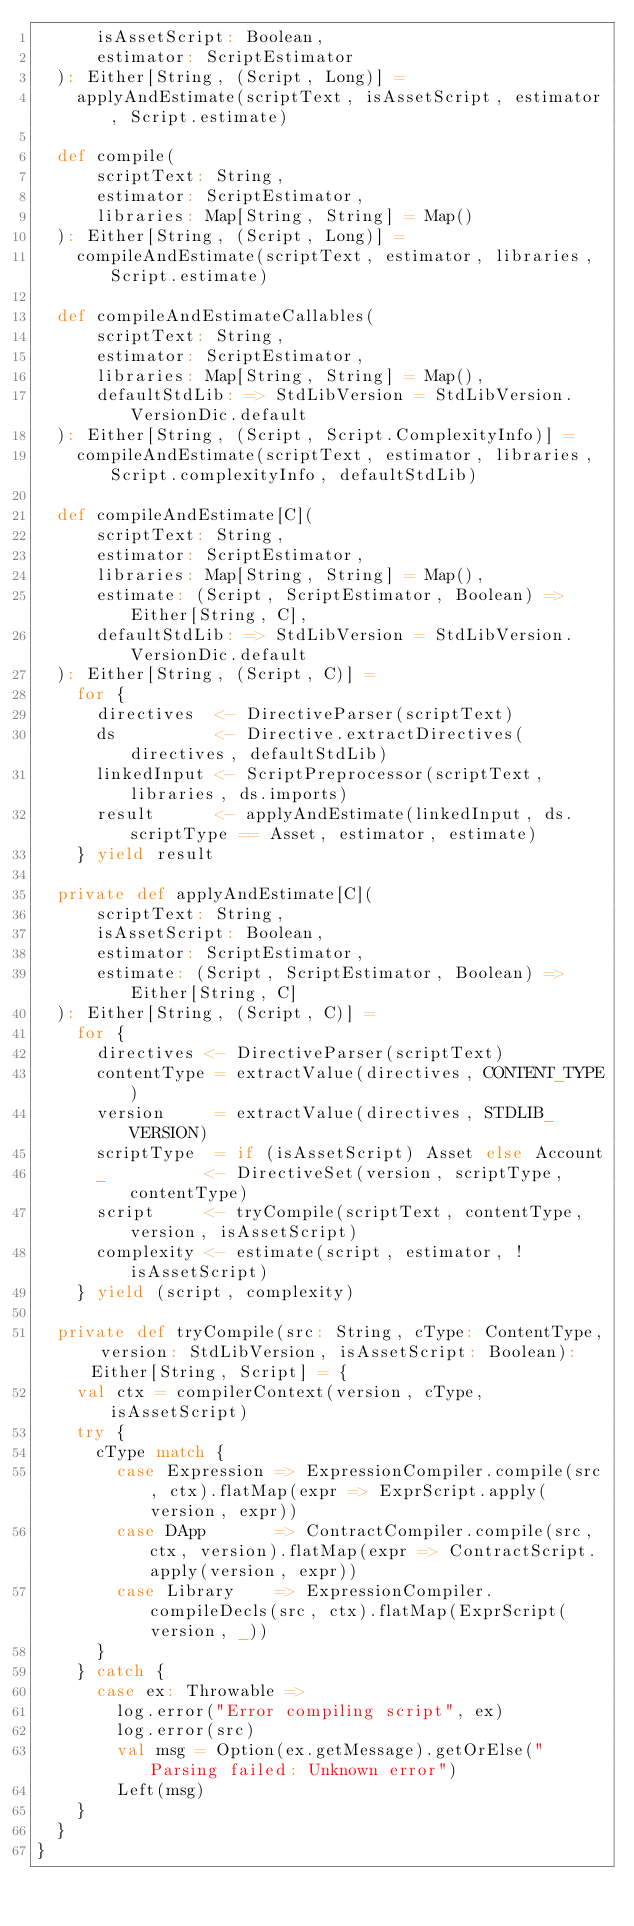Convert code to text. <code><loc_0><loc_0><loc_500><loc_500><_Scala_>      isAssetScript: Boolean,
      estimator: ScriptEstimator
  ): Either[String, (Script, Long)] =
    applyAndEstimate(scriptText, isAssetScript, estimator, Script.estimate)

  def compile(
      scriptText: String,
      estimator: ScriptEstimator,
      libraries: Map[String, String] = Map()
  ): Either[String, (Script, Long)] =
    compileAndEstimate(scriptText, estimator, libraries, Script.estimate)

  def compileAndEstimateCallables(
      scriptText: String,
      estimator: ScriptEstimator,
      libraries: Map[String, String] = Map(),
      defaultStdLib: => StdLibVersion = StdLibVersion.VersionDic.default
  ): Either[String, (Script, Script.ComplexityInfo)] =
    compileAndEstimate(scriptText, estimator, libraries, Script.complexityInfo, defaultStdLib)

  def compileAndEstimate[C](
      scriptText: String,
      estimator: ScriptEstimator,
      libraries: Map[String, String] = Map(),
      estimate: (Script, ScriptEstimator, Boolean) => Either[String, C],
      defaultStdLib: => StdLibVersion = StdLibVersion.VersionDic.default
  ): Either[String, (Script, C)] =
    for {
      directives  <- DirectiveParser(scriptText)
      ds          <- Directive.extractDirectives(directives, defaultStdLib)
      linkedInput <- ScriptPreprocessor(scriptText, libraries, ds.imports)
      result      <- applyAndEstimate(linkedInput, ds.scriptType == Asset, estimator, estimate)
    } yield result

  private def applyAndEstimate[C](
      scriptText: String,
      isAssetScript: Boolean,
      estimator: ScriptEstimator,
      estimate: (Script, ScriptEstimator, Boolean) => Either[String, C]
  ): Either[String, (Script, C)] =
    for {
      directives <- DirectiveParser(scriptText)
      contentType = extractValue(directives, CONTENT_TYPE)
      version     = extractValue(directives, STDLIB_VERSION)
      scriptType  = if (isAssetScript) Asset else Account
      _          <- DirectiveSet(version, scriptType, contentType)
      script     <- tryCompile(scriptText, contentType, version, isAssetScript)
      complexity <- estimate(script, estimator, !isAssetScript)
    } yield (script, complexity)

  private def tryCompile(src: String, cType: ContentType, version: StdLibVersion, isAssetScript: Boolean): Either[String, Script] = {
    val ctx = compilerContext(version, cType, isAssetScript)
    try {
      cType match {
        case Expression => ExpressionCompiler.compile(src, ctx).flatMap(expr => ExprScript.apply(version, expr))
        case DApp       => ContractCompiler.compile(src, ctx, version).flatMap(expr => ContractScript.apply(version, expr))
        case Library    => ExpressionCompiler.compileDecls(src, ctx).flatMap(ExprScript(version, _))
      }
    } catch {
      case ex: Throwable =>
        log.error("Error compiling script", ex)
        log.error(src)
        val msg = Option(ex.getMessage).getOrElse("Parsing failed: Unknown error")
        Left(msg)
    }
  }
}
</code> 